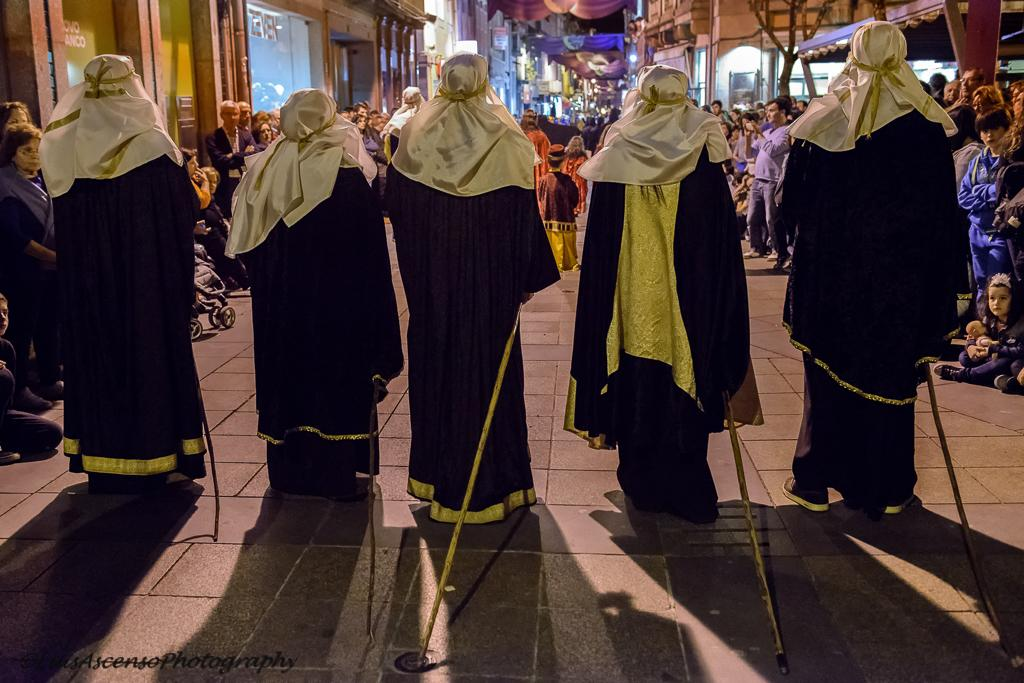How many people are present in the image are wearing black and golden dresses? There are five people in the image wearing black and golden dresses. What are the five people holding in their hands? Each of the five people is carrying a stick in their hands. Can you describe the people standing at the back in the image? There are additional people standing at the back in the image, and some of them are taking pictures. What type of bear can be seen interacting with the wax in the image? There is no bear or wax present in the image. How much dust is visible on the dresses of the people in the image? The provided facts do not mention any dust on the dresses of the people in the image. 